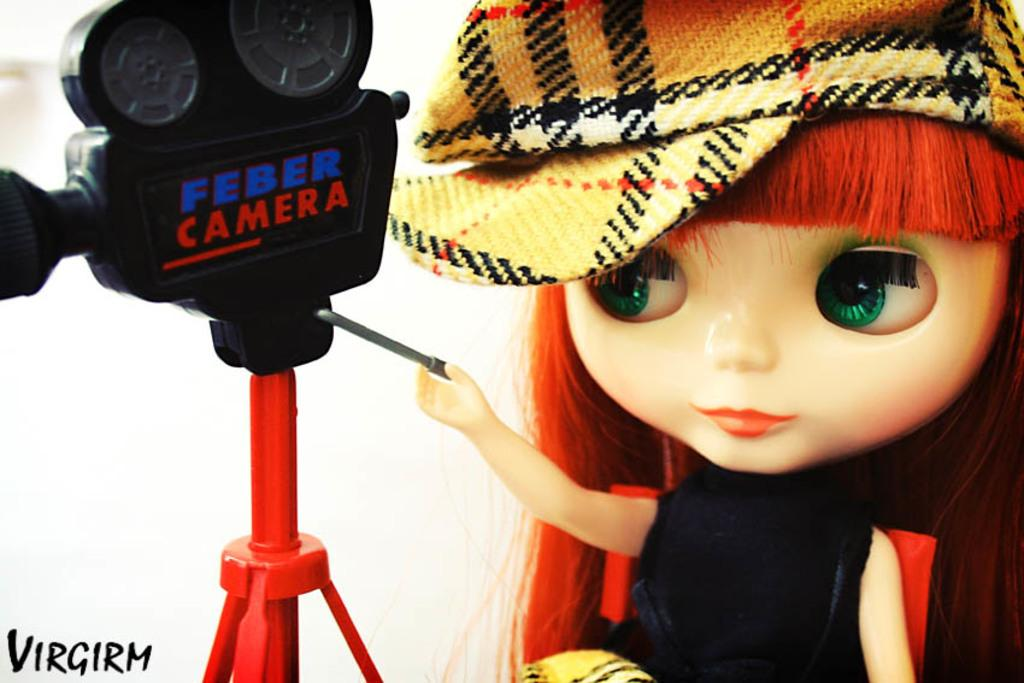What object can be seen on the right side of the image? There is a toy on the right side of the image. What is the toy wearing? The toy is wearing a hat. What is the toy holding in its hand? The toy is holding a stick. What type of device is on the left side of the image? There is a black color camera on the left side of the image. What other object can be seen on the left side of the image? There is a red color rod on the left side of the image. What type of clouds can be seen in the image? There are no clouds visible in the image; it only features a toy, a camera, and a red rod. 